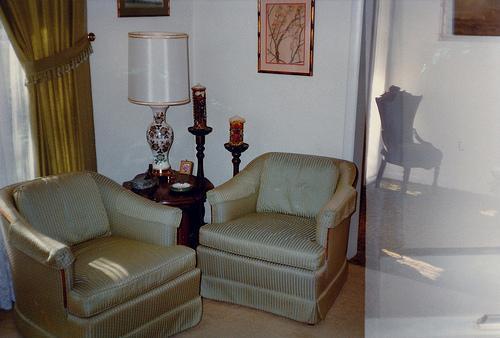How many candles are there?
Give a very brief answer. 2. 